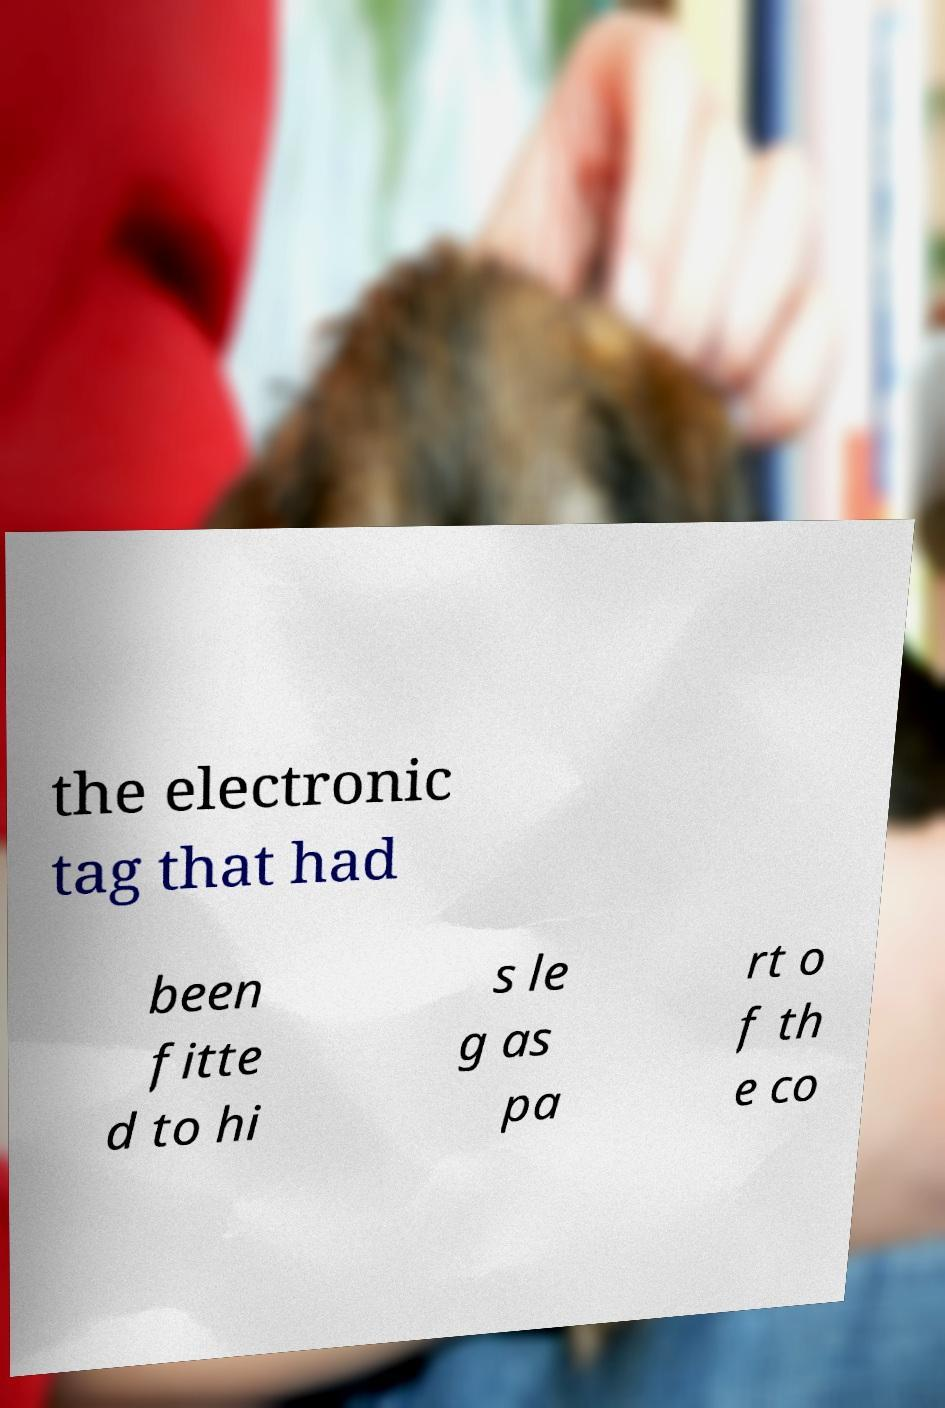Can you read and provide the text displayed in the image?This photo seems to have some interesting text. Can you extract and type it out for me? the electronic tag that had been fitte d to hi s le g as pa rt o f th e co 